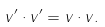Convert formula to latex. <formula><loc_0><loc_0><loc_500><loc_500>v ^ { \prime } \cdot v ^ { \prime } = v \cdot v .</formula> 